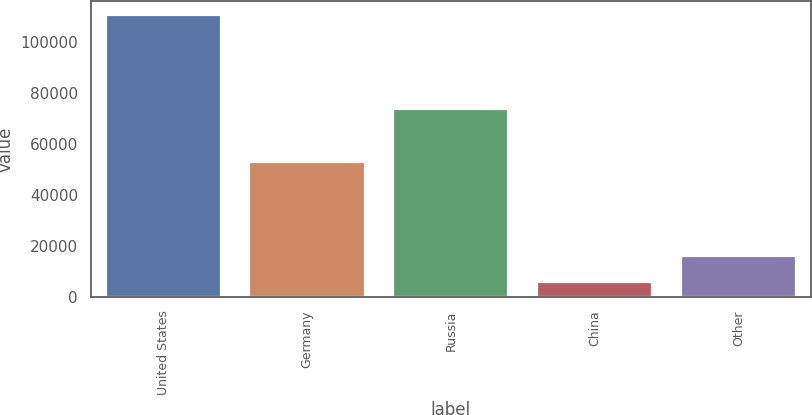Convert chart to OTSL. <chart><loc_0><loc_0><loc_500><loc_500><bar_chart><fcel>United States<fcel>Germany<fcel>Russia<fcel>China<fcel>Other<nl><fcel>110441<fcel>52791<fcel>73747<fcel>5895<fcel>16349.6<nl></chart> 